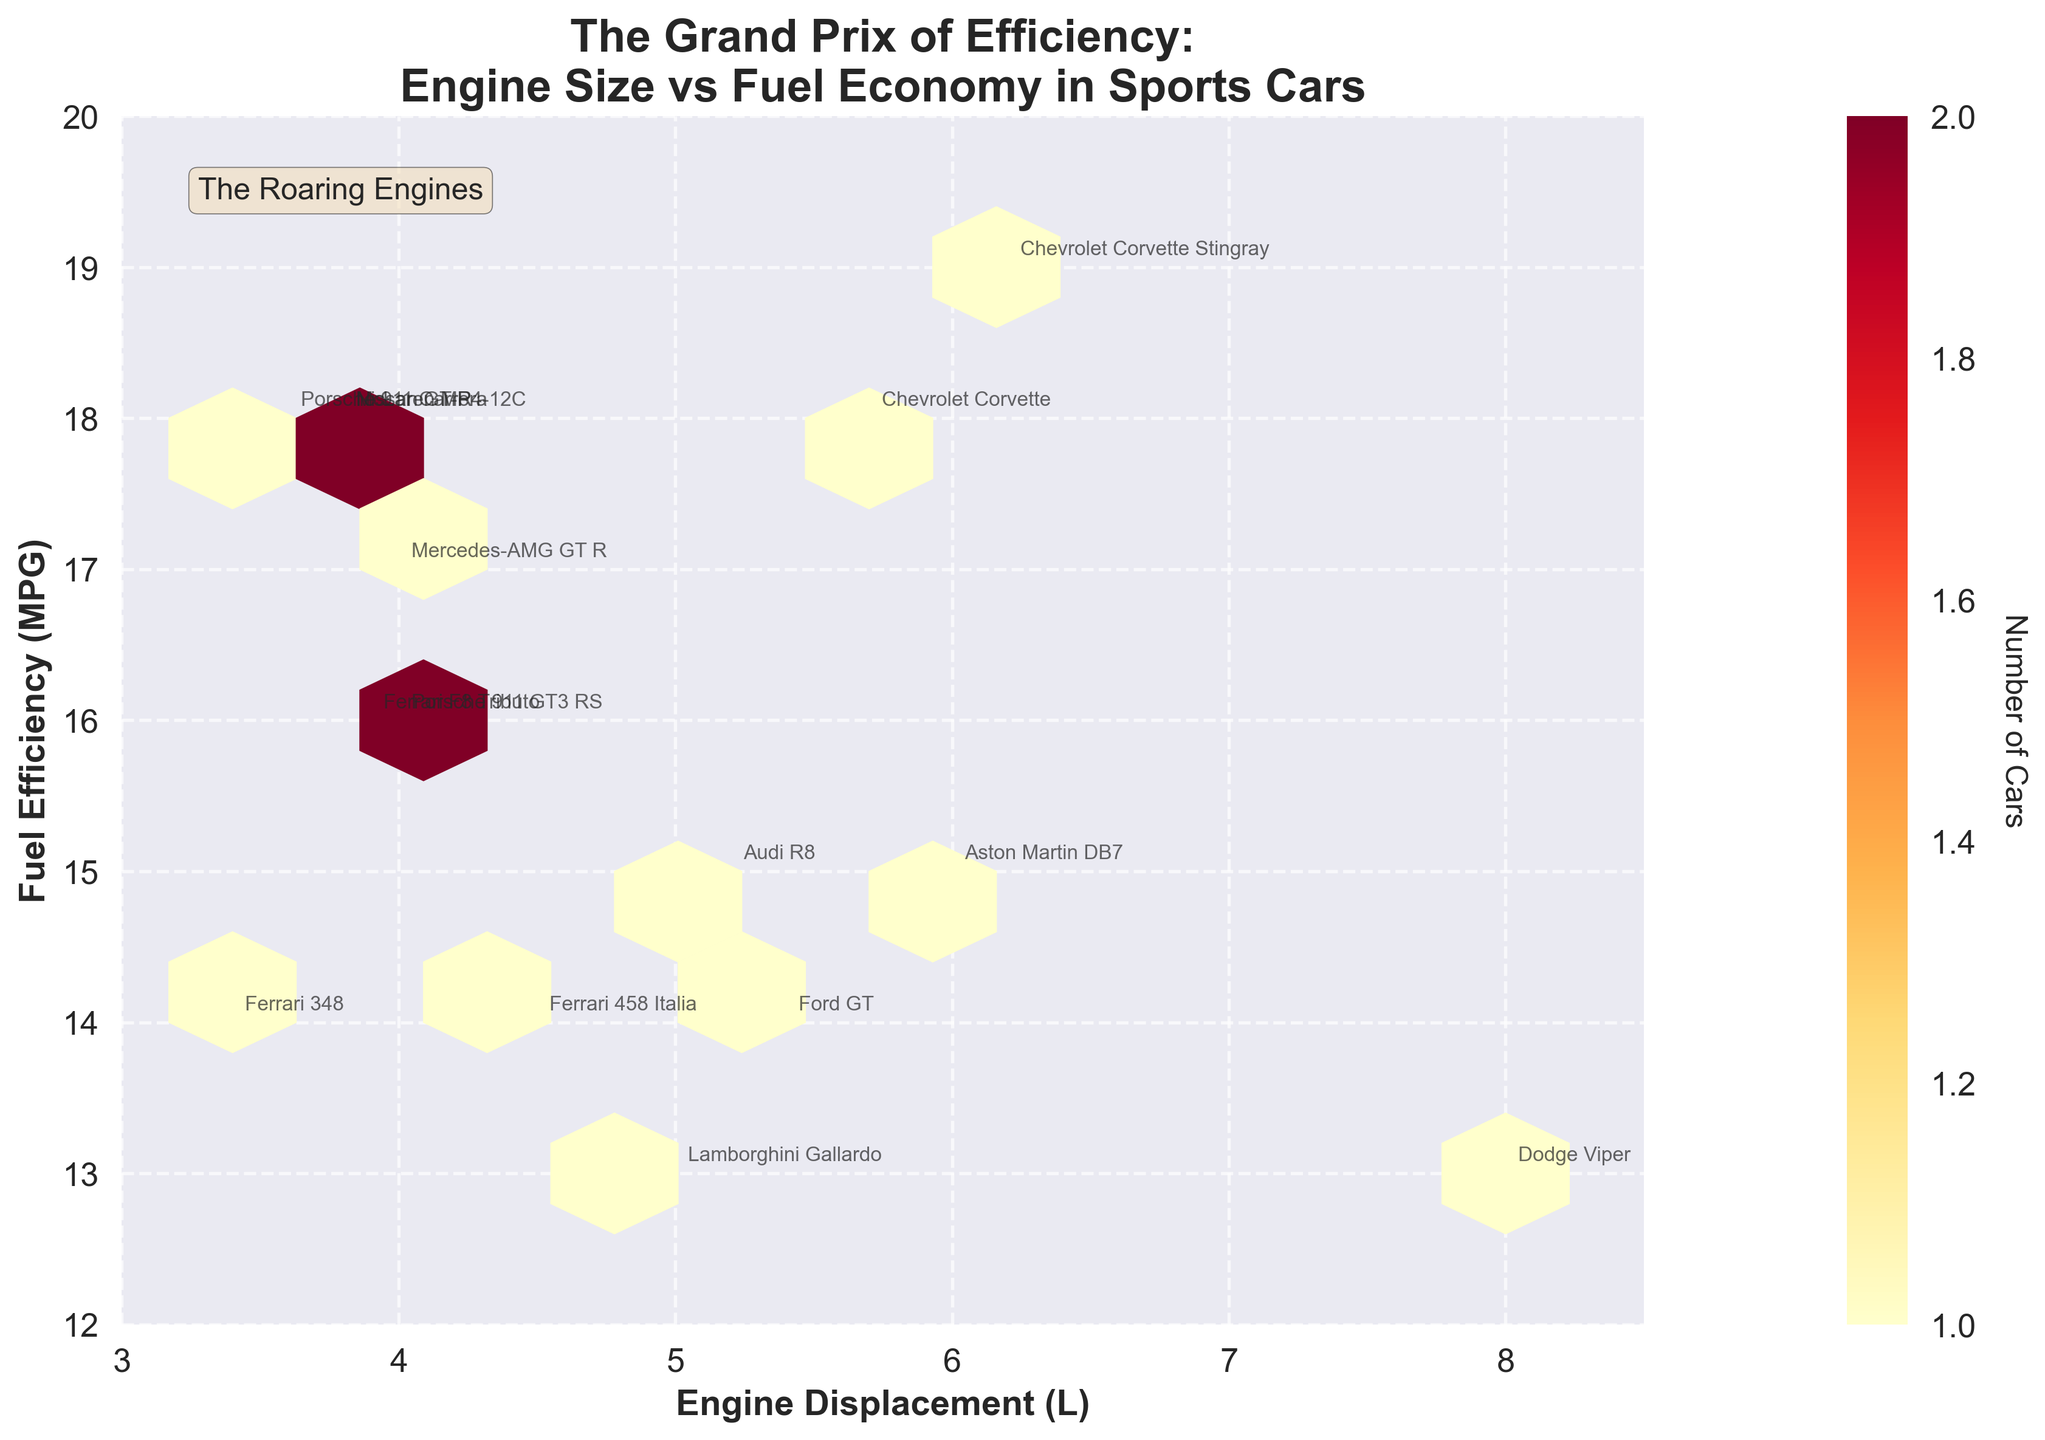Which model has the largest engine displacement? By observing the hexbin plot and the annotated text labels for each car model, identify the model with the largest engine displacement value.
Answer: Dodge Viper How many cars have a fuel efficiency of exactly 18 MPG? Look at the plot to find the hexbin that corresponds to a fuel efficiency of 18 MPG and count the number of cars annotated at this value.
Answer: 3 Does engine displacement generally increase or decrease fuel efficiency? Examine the overall trend from left (lower displacement) to right (higher displacement) in the hexbin plot to determine if fuel efficiency increases or decreases.
Answer: Decrease Which year had the car with the highest fuel efficiency? Identify the annotations and years on the plot, then compare the values to find the year with the highest MPG.
Answer: 2020 What is the range of fuel efficiencies observed in the plot? Identify the minimum and maximum MPG values annotated in the hexbin plot and find the difference between them to establish the range.
Answer: 12 to 20 MPG How many distinct hexagonal bins contain at least one car? Count the number of hexagonal bins that display a count, indicated by color, other than the background.
Answer: 6 Which car models fall in the 3.8L engine displacement and 18 MPG category? Identify cars annotated at the hexagonal bin for 3.8L displacement and 18 MPG on the plot.
Answer: Nissan GT-R, McLaren MP4-12C Which car had the lowest fuel efficiency in the year 1995? Check the annotations for the year 1995 and compare the fuel efficiencies, selecting the lowest one.
Answer: Dodge Viper How is the count of cars represented in the hexbin plot? Observe the color bar legend next to the plot, which indicates how the count of cars is visually represented by color shades.
Answer: By color shades 